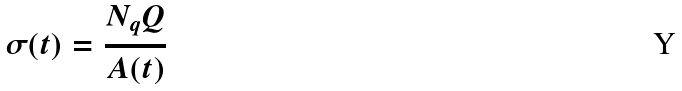<formula> <loc_0><loc_0><loc_500><loc_500>\sigma ( t ) = \frac { N _ { q } Q } { A ( t ) }</formula> 